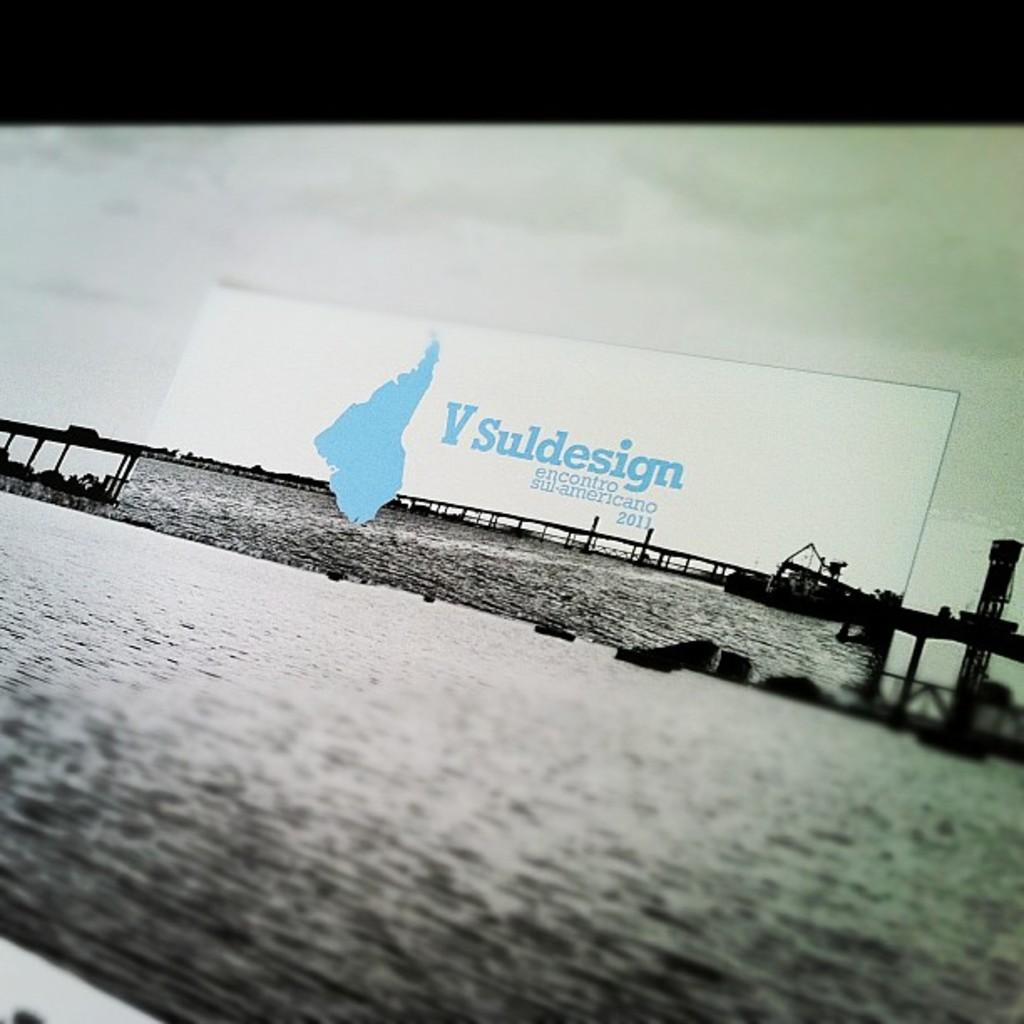<image>
Create a compact narrative representing the image presented. A sign displaying V Suldesign encontro sul-americano 2011 in blue letters 